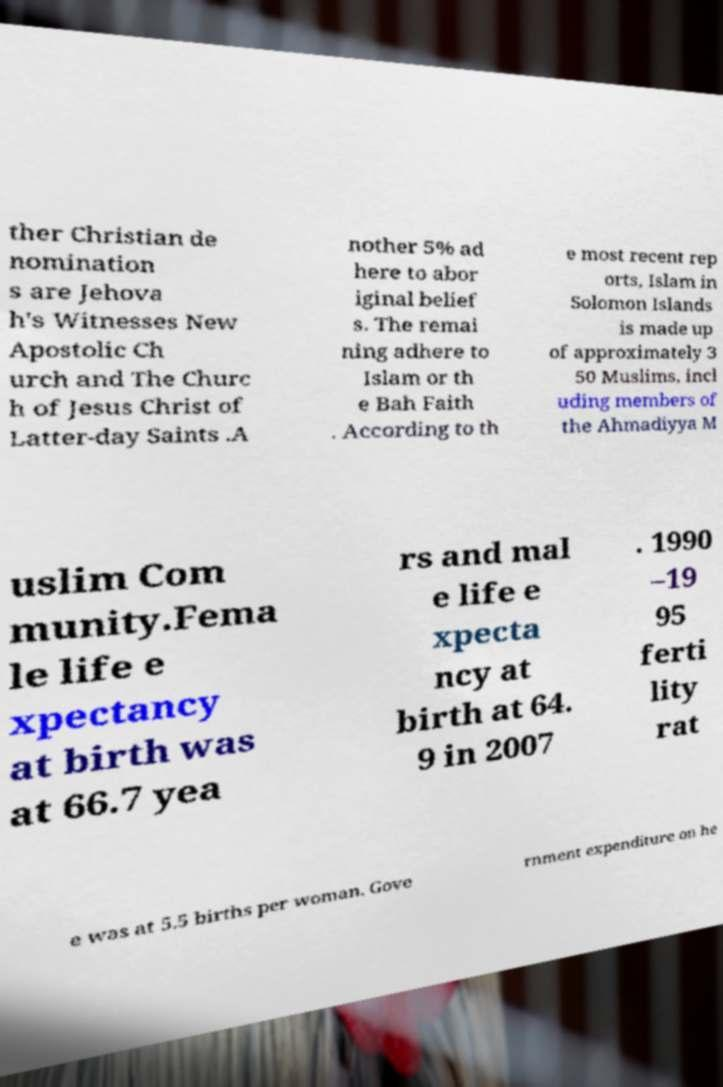Can you accurately transcribe the text from the provided image for me? ther Christian de nomination s are Jehova h's Witnesses New Apostolic Ch urch and The Churc h of Jesus Christ of Latter-day Saints .A nother 5% ad here to abor iginal belief s. The remai ning adhere to Islam or th e Bah Faith . According to th e most recent rep orts, Islam in Solomon Islands is made up of approximately 3 50 Muslims, incl uding members of the Ahmadiyya M uslim Com munity.Fema le life e xpectancy at birth was at 66.7 yea rs and mal e life e xpecta ncy at birth at 64. 9 in 2007 . 1990 –19 95 ferti lity rat e was at 5.5 births per woman. Gove rnment expenditure on he 